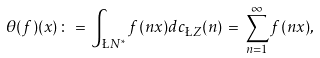Convert formula to latex. <formula><loc_0><loc_0><loc_500><loc_500>\theta ( f ) ( x ) \, \colon = \, \int _ { \L N ^ { * } } f ( n x ) d c _ { \L Z } ( n ) \, = \, \sum _ { n = 1 } ^ { \infty } f ( n x ) ,</formula> 